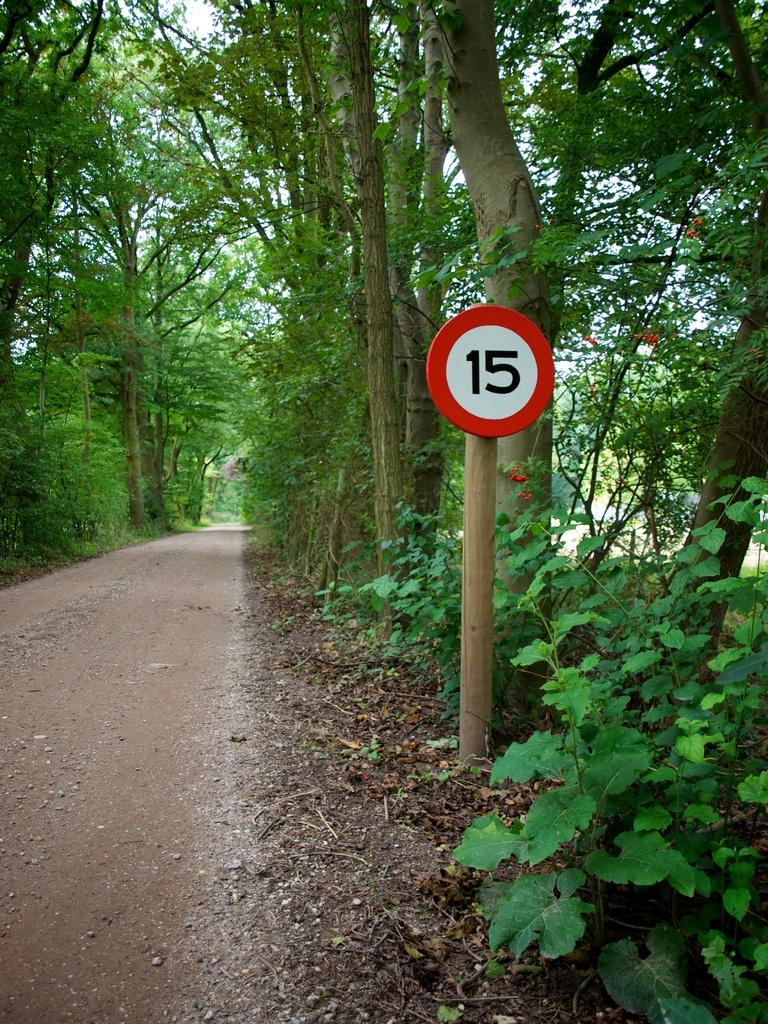<image>
Offer a succinct explanation of the picture presented. The red and white sign indicates that the speed limit is 15 on this road. 